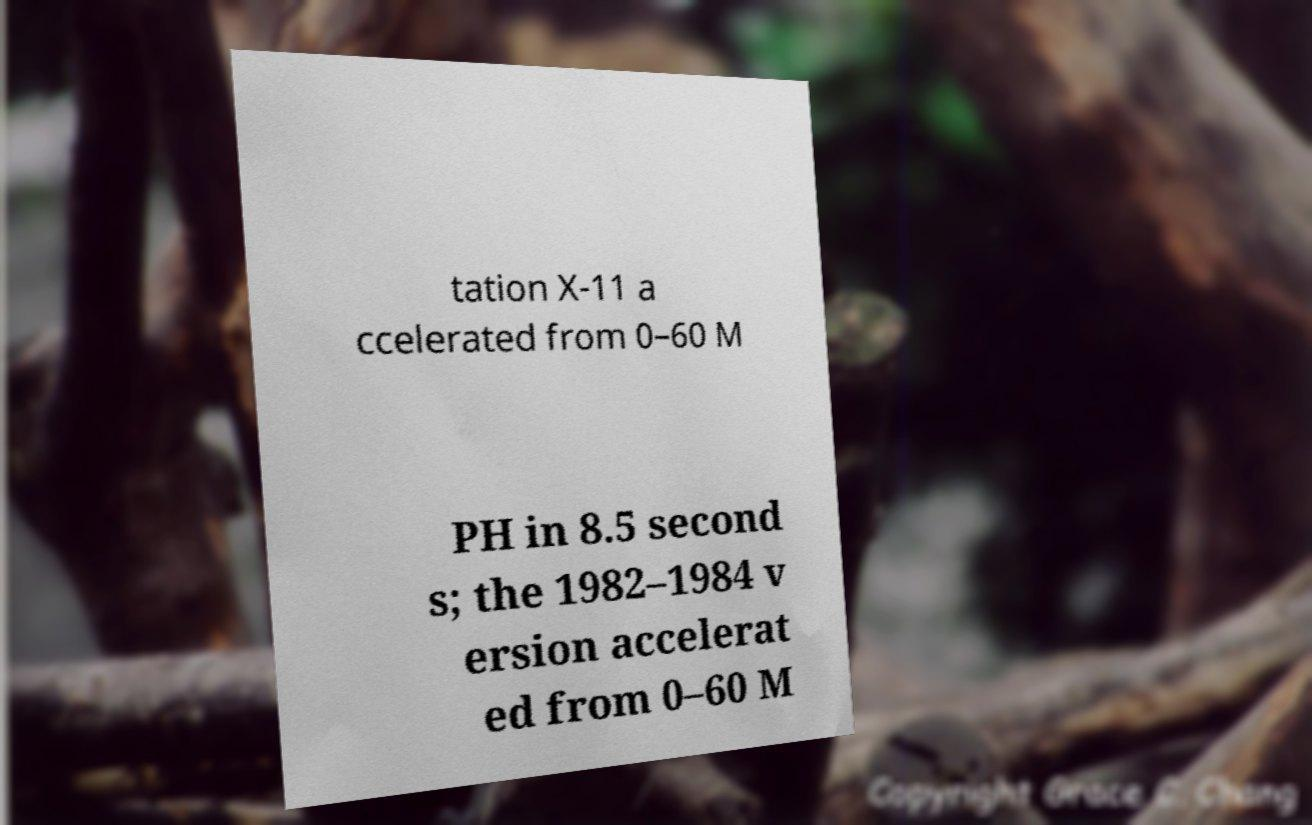Please read and relay the text visible in this image. What does it say? tation X-11 a ccelerated from 0–60 M PH in 8.5 second s; the 1982–1984 v ersion accelerat ed from 0–60 M 